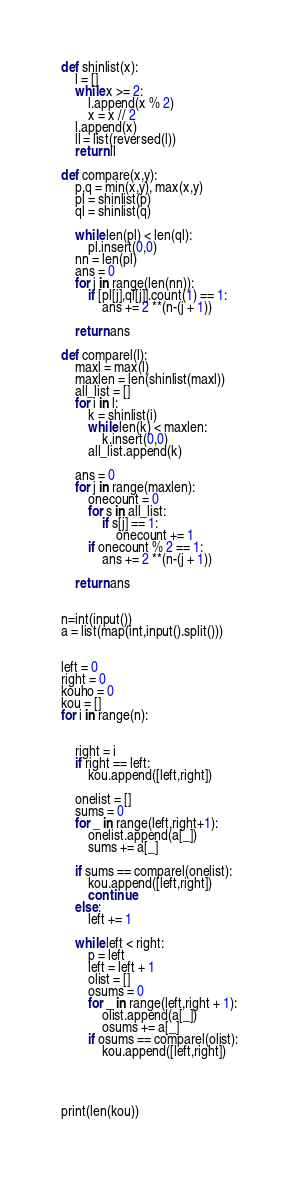<code> <loc_0><loc_0><loc_500><loc_500><_Python_>def shinlist(x):
    l = []
    while x >= 2:
        l.append(x % 2)
        x = x // 2
    l.append(x)
    ll = list(reversed(l))
    return ll

def compare(x,y):
    p,q = min(x,y), max(x,y)
    pl = shinlist(p)
    ql = shinlist(q)
    
    while len(pl) < len(ql):
        pl.insert(0,0)
    nn = len(pl)
    ans = 0
    for j in range(len(nn)):
        if [pl[j],ql[j]].count(1) == 1:
            ans += 2 **(n-(j + 1))
            
    return ans

def comparel(l):
    maxl = max(l)
    maxlen = len(shinlist(maxl))
    all_list = []
    for i in l:
        k = shinlist(i)
        while len(k) < maxlen:
            k.insert(0,0)
        all_list.append(k)
        
    ans = 0
    for j in range(maxlen):
        onecount = 0
        for s in all_list:
            if s[j] == 1:
                onecount += 1
        if onecount % 2 == 1:
            ans += 2 **(n-(j + 1))
            
    return ans


n=int(input())
a = list(map(int,input().split()))


left = 0 
right = 0
kouho = 0
kou = []
for i in range(n):
    
    
    right = i
    if right == left:
        kou.append([left,right])
        
    onelist = []
    sums = 0
    for _ in range(left,right+1):
        onelist.append(a[_])
        sums += a[_]
        
    if sums == comparel(onelist):
        kou.append([left,right])
        continue
    else:
        left += 1
    
    while left < right:
        p = left
        left = left + 1
        olist = []
        osums = 0
        for _ in range(left,right + 1):
            olist.append(a[_])
            osums += a[_]
        if osums == comparel(olist):
            kou.append([left,right])
                
            


print(len(kou))</code> 